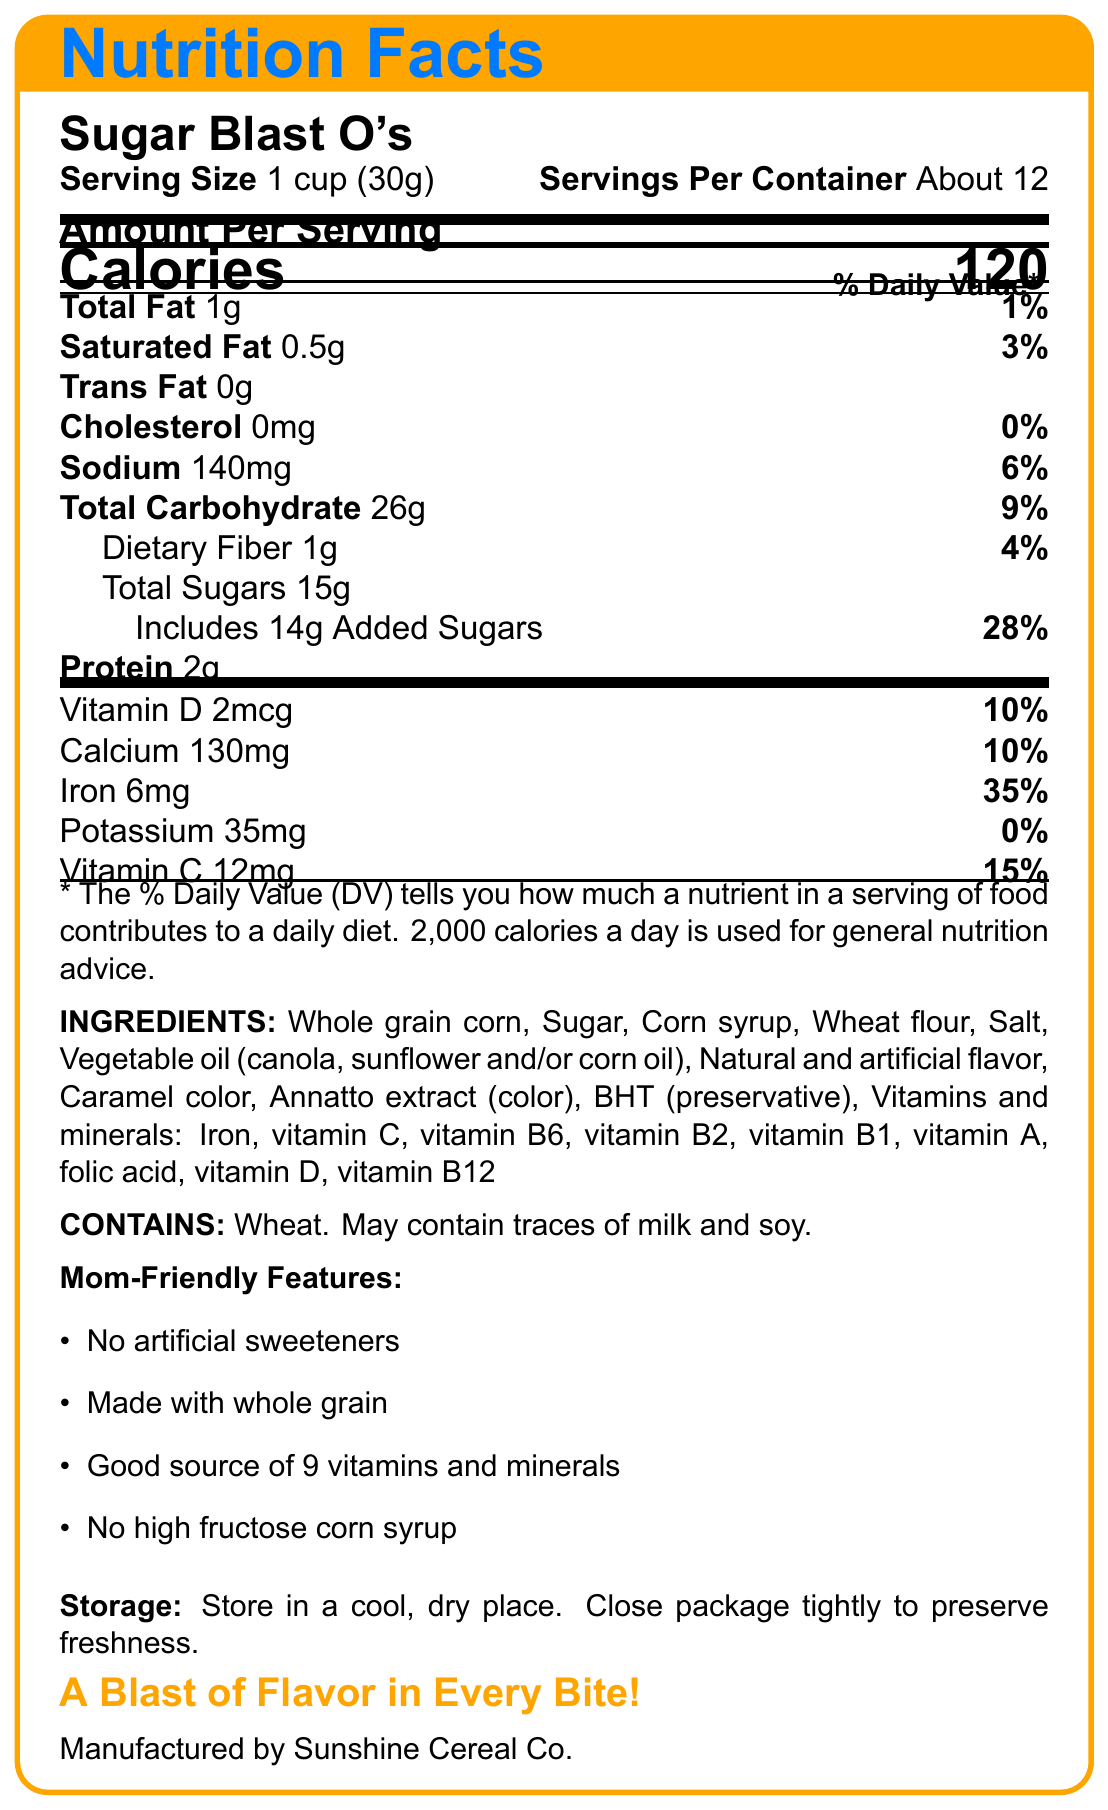What is the serving size of Sugar Blast O's? According to the document, the serving size is clearly stated as "1 cup (30g)".
Answer: 1 cup (30g) How many calories are in one serving of Sugar Blast O's? The nutrition facts label shows that there are 120 calories in one serving.
Answer: 120 What is the percentage of daily value for iron in a serving? The document states that a serving of this cereal provides 35% of the daily value for iron.
Answer: 35% How many grams of total sugars are in a serving? The document lists the amount of total sugars per serving as 15 grams.
Answer: 15g Does Sugar Blast O's contain any trans fat? The label reads "Trans Fat 0g", indicating there are no trans fats.
Answer: No Which of the following vitamins is found in the highest daily value percentage in one serving of Sugar Blast O's? A) Vitamin C B) Iron C) Vitamin D D) Vitamin B6 The daily value percentage for Iron is 35%, which is higher compared to the other vitamins listed.
Answer: B) Iron What is the serving size of Sugar Blast O's? A) 1/2 cup B) 1 cup (30g) C) 2 cups D) 30g The serving size is specified as 1 cup (30g) in the document.
Answer: B) 1 cup (30g) Which ingredients are not included in Sugar Blast O's? Select all that apply. I) Whole grain corn II) High fructose corn syrup III) Natural and artificial flavor IV) Honey The ingredients list does not include high fructose corn syrup or honey, but it does include whole grain corn and natural and artificial flavors.
Answer: II) High fructose corn syrup IV) Honey Is the box of Sugar Blast O's recyclable? The packaging information mentions that the box is recyclable where facilities exist.
Answer: Yes Can the allergen information determine if the product is safe for someone with a peanut allergy? The allergen information only states "Contains wheat. May contain traces of milk and soy." Peanuts are not mentioned, so it cannot be determined from the document.
Answer: No Summarize the main features of Sugar Blast O's from the nutrition facts label. This summary covers the key nutritional details, ingredients, mom-friendly features, allergen information, and packaging details of Sugar Blast O's.
Answer: Sugar Blast O's is a children's cereal with a serving size of 1 cup (30g) and about 12 servings per container. Each serving has 120 calories, 1g of fat, 140mg of sodium, 26g of carbohydrates (including 15g of total sugars and 14g of added sugars), and 2g of protein. It contains several vitamins and minerals, including vitamin D, calcium, iron, and vitamin B. The ingredients include whole grain corn, sugar, and corn syrup. It contains no artificial sweeteners, is made with whole grains, and is a good source of vitamins and minerals. The allergen information indicates it contains wheat and may contain traces of milk and soy. The packaging is recyclable where facilities exist. What is the total carbohydrate content in Sugar Blast O's? The document states that the total carbohydrate content for a serving is 26 grams.
Answer: 26g Is there any vitamin B12 in Sugar Blast O's? The nutrition facts list vitamin B12 with an amount of 0.6mcg and a daily value of 25%.
Answer: Yes 